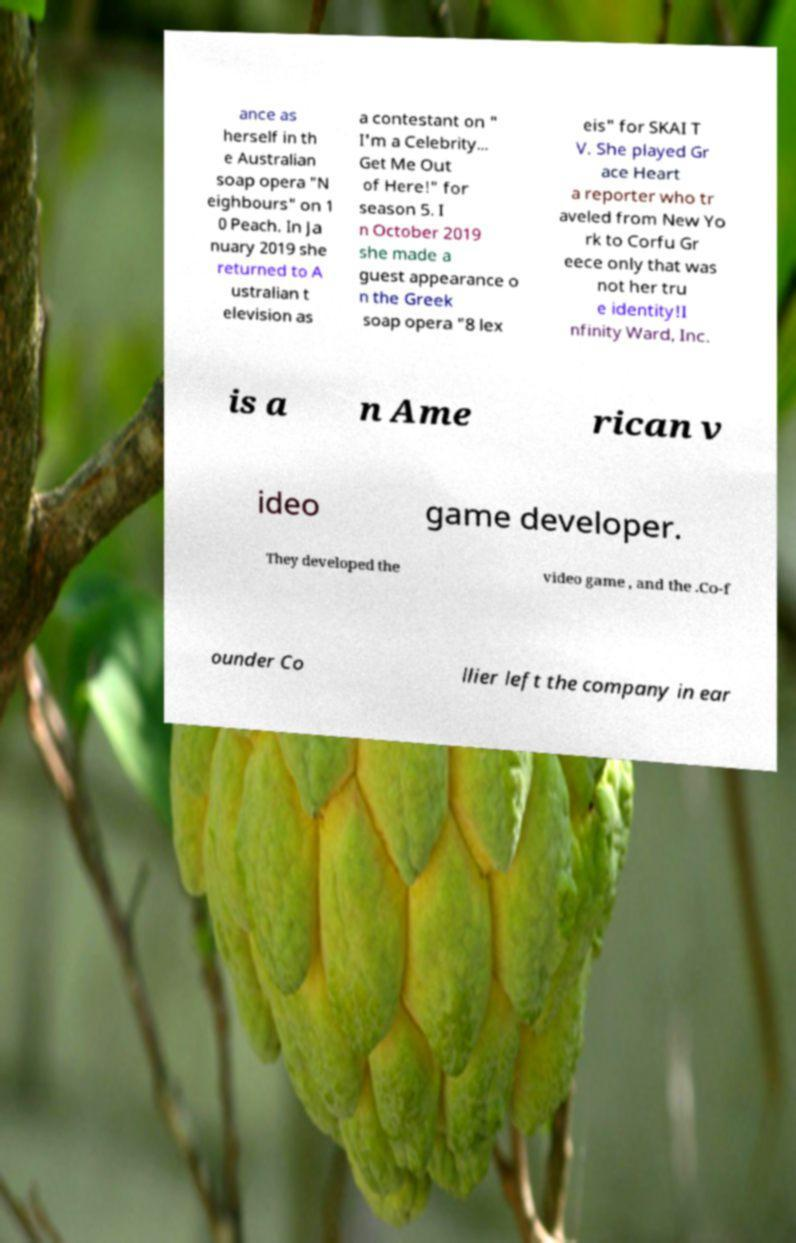There's text embedded in this image that I need extracted. Can you transcribe it verbatim? ance as herself in th e Australian soap opera "N eighbours" on 1 0 Peach. In Ja nuary 2019 she returned to A ustralian t elevision as a contestant on " I'm a Celebrity... Get Me Out of Here!" for season 5. I n October 2019 she made a guest appearance o n the Greek soap opera "8 lex eis" for SKAI T V. She played Gr ace Heart a reporter who tr aveled from New Yo rk to Corfu Gr eece only that was not her tru e identity!I nfinity Ward, Inc. is a n Ame rican v ideo game developer. They developed the video game , and the .Co-f ounder Co llier left the company in ear 